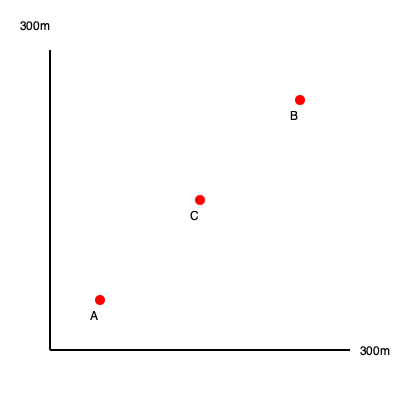Based on Dr. Warwick's history walks, estimate the distance between landmarks A and B on this simplified town plan of Burley. The grid represents 300m x 300m. To estimate the distance between landmarks A and B, we can follow these steps:

1. Observe that the landmarks form a right-angled triangle with C as the right angle.
2. The horizontal distance from A to C is approximately 100m (1/3 of 300m).
3. The vertical distance from C to B is approximately 200m (2/3 of 300m).
4. We can use the Pythagorean theorem to calculate the distance between A and B:

   $$AB^2 = AC^2 + BC^2$$
   $$AB^2 = 100^2 + 200^2$$
   $$AB^2 = 10,000 + 40,000 = 50,000$$
   $$AB = \sqrt{50,000} \approx 223.6$$

5. Rounding to the nearest 10 meters, the estimated distance is 220 meters.
Answer: 220 meters 